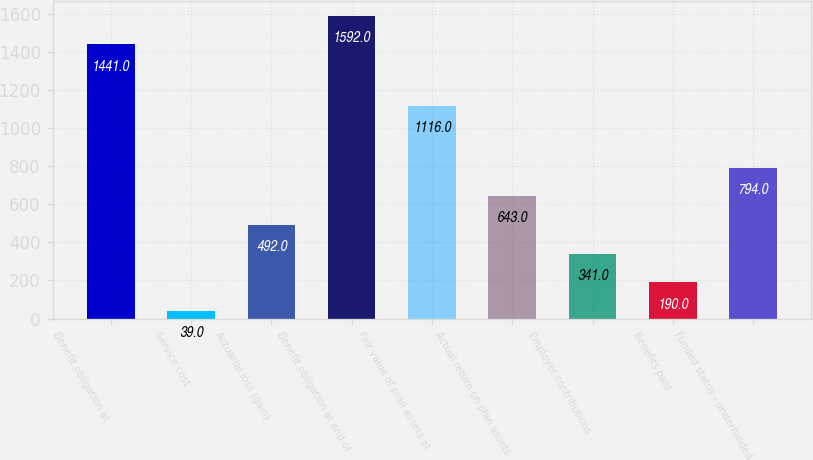<chart> <loc_0><loc_0><loc_500><loc_500><bar_chart><fcel>Benefit obligation at<fcel>Service cost<fcel>Actuarial loss (gain)<fcel>Benefit obligation at end of<fcel>Fair value of plan assets at<fcel>Actual return on plan assets<fcel>Employer contributions<fcel>Benefits paid<fcel>Funded status - underfunded<nl><fcel>1441<fcel>39<fcel>492<fcel>1592<fcel>1116<fcel>643<fcel>341<fcel>190<fcel>794<nl></chart> 